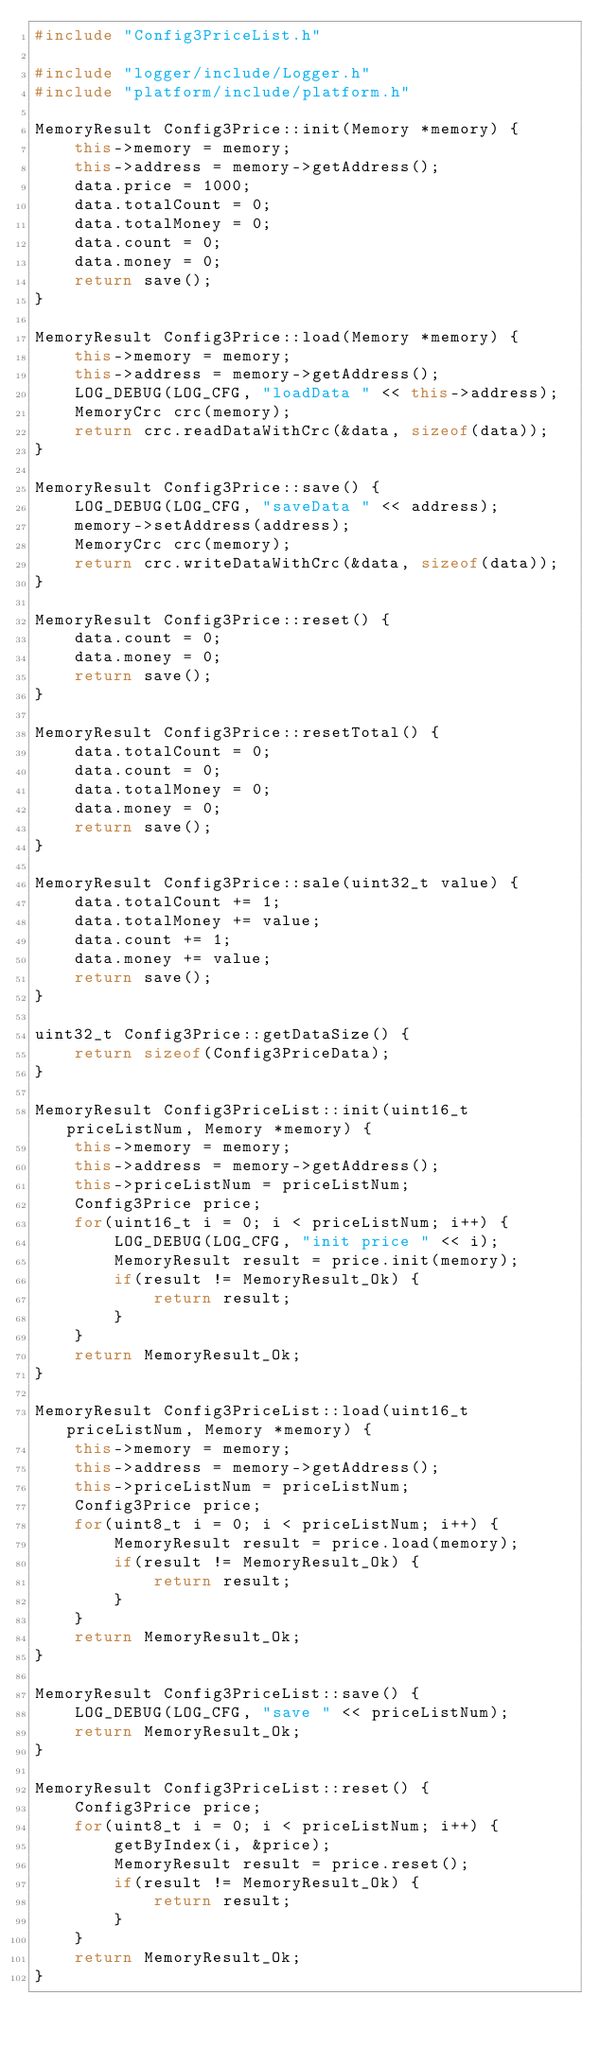<code> <loc_0><loc_0><loc_500><loc_500><_C++_>#include "Config3PriceList.h"

#include "logger/include/Logger.h"
#include "platform/include/platform.h"

MemoryResult Config3Price::init(Memory *memory) {
	this->memory = memory;
	this->address = memory->getAddress();
	data.price = 1000;
	data.totalCount = 0;
	data.totalMoney = 0;
	data.count = 0;
	data.money = 0;
	return save();
}

MemoryResult Config3Price::load(Memory *memory) {
	this->memory = memory;
	this->address = memory->getAddress();
	LOG_DEBUG(LOG_CFG, "loadData " << this->address);
	MemoryCrc crc(memory);
	return crc.readDataWithCrc(&data, sizeof(data));
}

MemoryResult Config3Price::save() {
	LOG_DEBUG(LOG_CFG, "saveData " << address);
	memory->setAddress(address);
	MemoryCrc crc(memory);
	return crc.writeDataWithCrc(&data, sizeof(data));
}

MemoryResult Config3Price::reset() {
	data.count = 0;
	data.money = 0;
	return save();
}

MemoryResult Config3Price::resetTotal() {
	data.totalCount = 0;
	data.count = 0;
	data.totalMoney = 0;
	data.money = 0;
	return save();
}

MemoryResult Config3Price::sale(uint32_t value) {
	data.totalCount += 1;
	data.totalMoney += value;
	data.count += 1;
	data.money += value;
	return save();
}

uint32_t Config3Price::getDataSize() {
	return sizeof(Config3PriceData);
}

MemoryResult Config3PriceList::init(uint16_t priceListNum, Memory *memory) {
	this->memory = memory;
	this->address = memory->getAddress();
	this->priceListNum = priceListNum;
	Config3Price price;
	for(uint16_t i = 0; i < priceListNum; i++) {
		LOG_DEBUG(LOG_CFG, "init price " << i);
		MemoryResult result = price.init(memory);
		if(result != MemoryResult_Ok) {
			return result;
		}
	}
	return MemoryResult_Ok;
}

MemoryResult Config3PriceList::load(uint16_t priceListNum, Memory *memory) {
	this->memory = memory;
	this->address = memory->getAddress();
	this->priceListNum = priceListNum;
	Config3Price price;
	for(uint8_t i = 0; i < priceListNum; i++) {
		MemoryResult result = price.load(memory);
		if(result != MemoryResult_Ok) {
			return result;
		}
	}
	return MemoryResult_Ok;
}

MemoryResult Config3PriceList::save() {
	LOG_DEBUG(LOG_CFG, "save " << priceListNum);
	return MemoryResult_Ok;
}

MemoryResult Config3PriceList::reset() {
	Config3Price price;
	for(uint8_t i = 0; i < priceListNum; i++) {
		getByIndex(i, &price);
		MemoryResult result = price.reset();
		if(result != MemoryResult_Ok) {
			return result;
		}
	}
	return MemoryResult_Ok;
}
</code> 